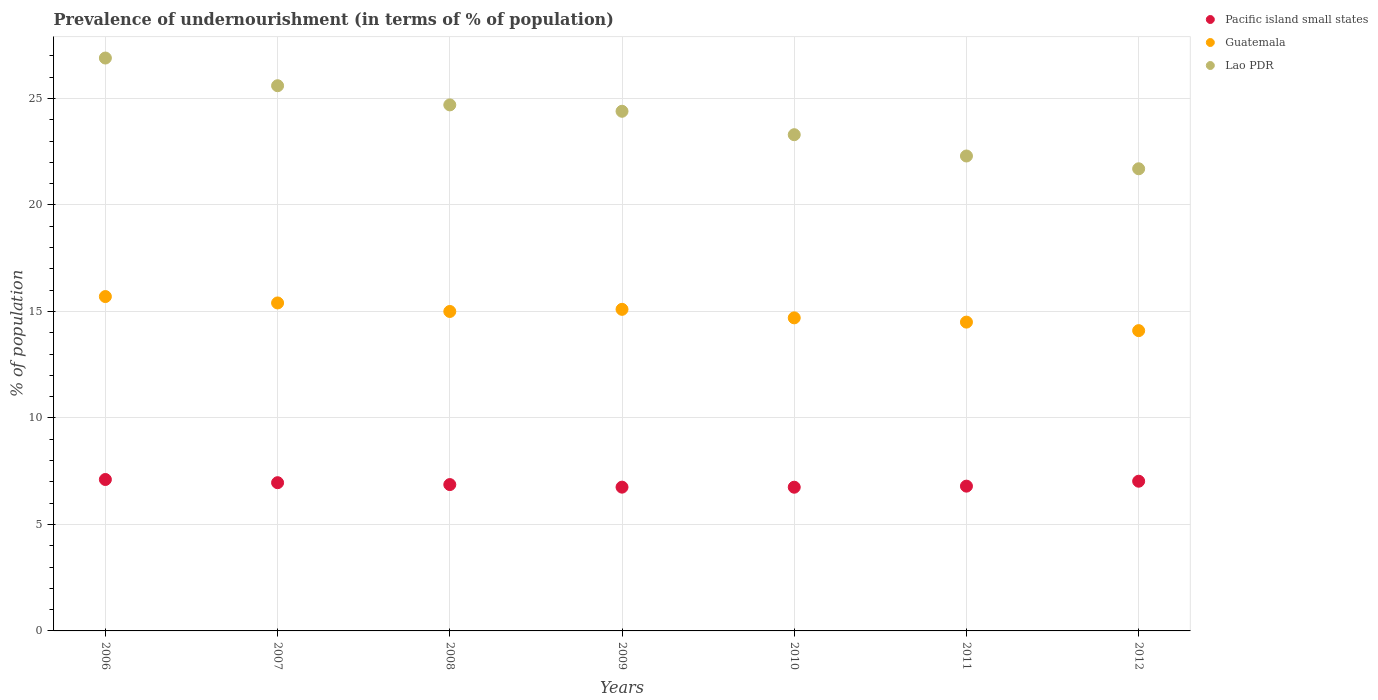Is the number of dotlines equal to the number of legend labels?
Make the answer very short. Yes. What is the percentage of undernourished population in Guatemala in 2009?
Offer a terse response. 15.1. Across all years, what is the minimum percentage of undernourished population in Lao PDR?
Make the answer very short. 21.7. In which year was the percentage of undernourished population in Guatemala maximum?
Your response must be concise. 2006. In which year was the percentage of undernourished population in Guatemala minimum?
Keep it short and to the point. 2012. What is the total percentage of undernourished population in Lao PDR in the graph?
Keep it short and to the point. 168.9. What is the difference between the percentage of undernourished population in Pacific island small states in 2010 and that in 2012?
Your answer should be compact. -0.28. What is the difference between the percentage of undernourished population in Lao PDR in 2011 and the percentage of undernourished population in Pacific island small states in 2010?
Provide a short and direct response. 15.55. What is the average percentage of undernourished population in Pacific island small states per year?
Provide a succinct answer. 6.9. In the year 2009, what is the difference between the percentage of undernourished population in Guatemala and percentage of undernourished population in Pacific island small states?
Provide a short and direct response. 8.35. What is the ratio of the percentage of undernourished population in Pacific island small states in 2009 to that in 2011?
Your answer should be compact. 0.99. Is the percentage of undernourished population in Lao PDR in 2008 less than that in 2009?
Give a very brief answer. No. What is the difference between the highest and the second highest percentage of undernourished population in Guatemala?
Offer a very short reply. 0.3. What is the difference between the highest and the lowest percentage of undernourished population in Pacific island small states?
Provide a short and direct response. 0.36. Is the percentage of undernourished population in Guatemala strictly greater than the percentage of undernourished population in Lao PDR over the years?
Give a very brief answer. No. Is the percentage of undernourished population in Guatemala strictly less than the percentage of undernourished population in Lao PDR over the years?
Your answer should be very brief. Yes. How many dotlines are there?
Your answer should be compact. 3. How many years are there in the graph?
Provide a succinct answer. 7. What is the difference between two consecutive major ticks on the Y-axis?
Offer a very short reply. 5. Are the values on the major ticks of Y-axis written in scientific E-notation?
Provide a succinct answer. No. Where does the legend appear in the graph?
Make the answer very short. Top right. How are the legend labels stacked?
Offer a very short reply. Vertical. What is the title of the graph?
Give a very brief answer. Prevalence of undernourishment (in terms of % of population). What is the label or title of the Y-axis?
Your answer should be compact. % of population. What is the % of population of Pacific island small states in 2006?
Provide a succinct answer. 7.11. What is the % of population of Lao PDR in 2006?
Your response must be concise. 26.9. What is the % of population in Pacific island small states in 2007?
Offer a very short reply. 6.96. What is the % of population in Lao PDR in 2007?
Provide a succinct answer. 25.6. What is the % of population in Pacific island small states in 2008?
Your answer should be compact. 6.87. What is the % of population of Guatemala in 2008?
Your answer should be very brief. 15. What is the % of population in Lao PDR in 2008?
Make the answer very short. 24.7. What is the % of population of Pacific island small states in 2009?
Your answer should be very brief. 6.75. What is the % of population of Lao PDR in 2009?
Offer a terse response. 24.4. What is the % of population of Pacific island small states in 2010?
Ensure brevity in your answer.  6.75. What is the % of population of Lao PDR in 2010?
Ensure brevity in your answer.  23.3. What is the % of population of Pacific island small states in 2011?
Your answer should be very brief. 6.8. What is the % of population in Lao PDR in 2011?
Your response must be concise. 22.3. What is the % of population of Pacific island small states in 2012?
Provide a short and direct response. 7.03. What is the % of population of Guatemala in 2012?
Provide a short and direct response. 14.1. What is the % of population of Lao PDR in 2012?
Give a very brief answer. 21.7. Across all years, what is the maximum % of population of Pacific island small states?
Your response must be concise. 7.11. Across all years, what is the maximum % of population in Lao PDR?
Give a very brief answer. 26.9. Across all years, what is the minimum % of population in Pacific island small states?
Ensure brevity in your answer.  6.75. Across all years, what is the minimum % of population of Guatemala?
Give a very brief answer. 14.1. Across all years, what is the minimum % of population of Lao PDR?
Give a very brief answer. 21.7. What is the total % of population in Pacific island small states in the graph?
Your answer should be very brief. 48.27. What is the total % of population in Guatemala in the graph?
Make the answer very short. 104.5. What is the total % of population of Lao PDR in the graph?
Ensure brevity in your answer.  168.9. What is the difference between the % of population of Pacific island small states in 2006 and that in 2007?
Provide a succinct answer. 0.15. What is the difference between the % of population of Guatemala in 2006 and that in 2007?
Your answer should be compact. 0.3. What is the difference between the % of population of Pacific island small states in 2006 and that in 2008?
Your answer should be compact. 0.24. What is the difference between the % of population of Guatemala in 2006 and that in 2008?
Give a very brief answer. 0.7. What is the difference between the % of population in Pacific island small states in 2006 and that in 2009?
Offer a terse response. 0.36. What is the difference between the % of population in Guatemala in 2006 and that in 2009?
Your answer should be very brief. 0.6. What is the difference between the % of population in Lao PDR in 2006 and that in 2009?
Ensure brevity in your answer.  2.5. What is the difference between the % of population of Pacific island small states in 2006 and that in 2010?
Keep it short and to the point. 0.36. What is the difference between the % of population in Guatemala in 2006 and that in 2010?
Offer a terse response. 1. What is the difference between the % of population in Lao PDR in 2006 and that in 2010?
Keep it short and to the point. 3.6. What is the difference between the % of population of Pacific island small states in 2006 and that in 2011?
Give a very brief answer. 0.31. What is the difference between the % of population in Lao PDR in 2006 and that in 2011?
Provide a short and direct response. 4.6. What is the difference between the % of population in Pacific island small states in 2006 and that in 2012?
Make the answer very short. 0.08. What is the difference between the % of population in Pacific island small states in 2007 and that in 2008?
Give a very brief answer. 0.09. What is the difference between the % of population of Guatemala in 2007 and that in 2008?
Provide a short and direct response. 0.4. What is the difference between the % of population of Lao PDR in 2007 and that in 2008?
Provide a succinct answer. 0.9. What is the difference between the % of population in Pacific island small states in 2007 and that in 2009?
Offer a terse response. 0.21. What is the difference between the % of population of Lao PDR in 2007 and that in 2009?
Offer a very short reply. 1.2. What is the difference between the % of population in Pacific island small states in 2007 and that in 2010?
Keep it short and to the point. 0.21. What is the difference between the % of population of Guatemala in 2007 and that in 2010?
Provide a succinct answer. 0.7. What is the difference between the % of population in Lao PDR in 2007 and that in 2010?
Give a very brief answer. 2.3. What is the difference between the % of population of Pacific island small states in 2007 and that in 2011?
Offer a very short reply. 0.16. What is the difference between the % of population of Lao PDR in 2007 and that in 2011?
Your answer should be compact. 3.3. What is the difference between the % of population in Pacific island small states in 2007 and that in 2012?
Ensure brevity in your answer.  -0.07. What is the difference between the % of population of Lao PDR in 2007 and that in 2012?
Your answer should be compact. 3.9. What is the difference between the % of population in Pacific island small states in 2008 and that in 2009?
Make the answer very short. 0.12. What is the difference between the % of population of Guatemala in 2008 and that in 2009?
Offer a very short reply. -0.1. What is the difference between the % of population in Lao PDR in 2008 and that in 2009?
Your answer should be compact. 0.3. What is the difference between the % of population of Pacific island small states in 2008 and that in 2010?
Make the answer very short. 0.12. What is the difference between the % of population in Pacific island small states in 2008 and that in 2011?
Make the answer very short. 0.07. What is the difference between the % of population of Lao PDR in 2008 and that in 2011?
Provide a succinct answer. 2.4. What is the difference between the % of population in Pacific island small states in 2008 and that in 2012?
Provide a succinct answer. -0.16. What is the difference between the % of population in Lao PDR in 2008 and that in 2012?
Offer a very short reply. 3. What is the difference between the % of population in Pacific island small states in 2009 and that in 2010?
Provide a short and direct response. 0. What is the difference between the % of population in Guatemala in 2009 and that in 2010?
Offer a terse response. 0.4. What is the difference between the % of population of Lao PDR in 2009 and that in 2010?
Offer a very short reply. 1.1. What is the difference between the % of population in Pacific island small states in 2009 and that in 2011?
Provide a short and direct response. -0.05. What is the difference between the % of population of Guatemala in 2009 and that in 2011?
Give a very brief answer. 0.6. What is the difference between the % of population in Lao PDR in 2009 and that in 2011?
Your answer should be very brief. 2.1. What is the difference between the % of population in Pacific island small states in 2009 and that in 2012?
Ensure brevity in your answer.  -0.28. What is the difference between the % of population of Guatemala in 2009 and that in 2012?
Provide a succinct answer. 1. What is the difference between the % of population in Lao PDR in 2009 and that in 2012?
Keep it short and to the point. 2.7. What is the difference between the % of population of Pacific island small states in 2010 and that in 2011?
Provide a succinct answer. -0.05. What is the difference between the % of population in Lao PDR in 2010 and that in 2011?
Your answer should be compact. 1. What is the difference between the % of population in Pacific island small states in 2010 and that in 2012?
Your answer should be very brief. -0.28. What is the difference between the % of population of Pacific island small states in 2011 and that in 2012?
Make the answer very short. -0.23. What is the difference between the % of population of Lao PDR in 2011 and that in 2012?
Offer a terse response. 0.6. What is the difference between the % of population in Pacific island small states in 2006 and the % of population in Guatemala in 2007?
Ensure brevity in your answer.  -8.29. What is the difference between the % of population in Pacific island small states in 2006 and the % of population in Lao PDR in 2007?
Make the answer very short. -18.49. What is the difference between the % of population in Guatemala in 2006 and the % of population in Lao PDR in 2007?
Offer a very short reply. -9.9. What is the difference between the % of population of Pacific island small states in 2006 and the % of population of Guatemala in 2008?
Offer a terse response. -7.89. What is the difference between the % of population in Pacific island small states in 2006 and the % of population in Lao PDR in 2008?
Keep it short and to the point. -17.59. What is the difference between the % of population in Guatemala in 2006 and the % of population in Lao PDR in 2008?
Keep it short and to the point. -9. What is the difference between the % of population of Pacific island small states in 2006 and the % of population of Guatemala in 2009?
Your answer should be very brief. -7.99. What is the difference between the % of population of Pacific island small states in 2006 and the % of population of Lao PDR in 2009?
Your answer should be very brief. -17.29. What is the difference between the % of population in Guatemala in 2006 and the % of population in Lao PDR in 2009?
Make the answer very short. -8.7. What is the difference between the % of population of Pacific island small states in 2006 and the % of population of Guatemala in 2010?
Provide a short and direct response. -7.59. What is the difference between the % of population in Pacific island small states in 2006 and the % of population in Lao PDR in 2010?
Make the answer very short. -16.19. What is the difference between the % of population in Pacific island small states in 2006 and the % of population in Guatemala in 2011?
Offer a very short reply. -7.39. What is the difference between the % of population in Pacific island small states in 2006 and the % of population in Lao PDR in 2011?
Ensure brevity in your answer.  -15.19. What is the difference between the % of population in Guatemala in 2006 and the % of population in Lao PDR in 2011?
Offer a terse response. -6.6. What is the difference between the % of population of Pacific island small states in 2006 and the % of population of Guatemala in 2012?
Provide a short and direct response. -6.99. What is the difference between the % of population of Pacific island small states in 2006 and the % of population of Lao PDR in 2012?
Provide a succinct answer. -14.59. What is the difference between the % of population in Pacific island small states in 2007 and the % of population in Guatemala in 2008?
Provide a succinct answer. -8.04. What is the difference between the % of population in Pacific island small states in 2007 and the % of population in Lao PDR in 2008?
Offer a very short reply. -17.74. What is the difference between the % of population in Guatemala in 2007 and the % of population in Lao PDR in 2008?
Ensure brevity in your answer.  -9.3. What is the difference between the % of population in Pacific island small states in 2007 and the % of population in Guatemala in 2009?
Give a very brief answer. -8.14. What is the difference between the % of population of Pacific island small states in 2007 and the % of population of Lao PDR in 2009?
Keep it short and to the point. -17.44. What is the difference between the % of population in Pacific island small states in 2007 and the % of population in Guatemala in 2010?
Provide a short and direct response. -7.74. What is the difference between the % of population in Pacific island small states in 2007 and the % of population in Lao PDR in 2010?
Ensure brevity in your answer.  -16.34. What is the difference between the % of population of Guatemala in 2007 and the % of population of Lao PDR in 2010?
Offer a terse response. -7.9. What is the difference between the % of population of Pacific island small states in 2007 and the % of population of Guatemala in 2011?
Offer a terse response. -7.54. What is the difference between the % of population in Pacific island small states in 2007 and the % of population in Lao PDR in 2011?
Your answer should be very brief. -15.34. What is the difference between the % of population in Pacific island small states in 2007 and the % of population in Guatemala in 2012?
Ensure brevity in your answer.  -7.14. What is the difference between the % of population of Pacific island small states in 2007 and the % of population of Lao PDR in 2012?
Your answer should be very brief. -14.74. What is the difference between the % of population of Pacific island small states in 2008 and the % of population of Guatemala in 2009?
Your answer should be very brief. -8.23. What is the difference between the % of population of Pacific island small states in 2008 and the % of population of Lao PDR in 2009?
Your answer should be compact. -17.53. What is the difference between the % of population of Pacific island small states in 2008 and the % of population of Guatemala in 2010?
Keep it short and to the point. -7.83. What is the difference between the % of population in Pacific island small states in 2008 and the % of population in Lao PDR in 2010?
Provide a short and direct response. -16.43. What is the difference between the % of population of Guatemala in 2008 and the % of population of Lao PDR in 2010?
Your answer should be compact. -8.3. What is the difference between the % of population of Pacific island small states in 2008 and the % of population of Guatemala in 2011?
Your answer should be compact. -7.63. What is the difference between the % of population of Pacific island small states in 2008 and the % of population of Lao PDR in 2011?
Ensure brevity in your answer.  -15.43. What is the difference between the % of population in Guatemala in 2008 and the % of population in Lao PDR in 2011?
Your response must be concise. -7.3. What is the difference between the % of population in Pacific island small states in 2008 and the % of population in Guatemala in 2012?
Make the answer very short. -7.23. What is the difference between the % of population of Pacific island small states in 2008 and the % of population of Lao PDR in 2012?
Give a very brief answer. -14.83. What is the difference between the % of population in Guatemala in 2008 and the % of population in Lao PDR in 2012?
Provide a succinct answer. -6.7. What is the difference between the % of population in Pacific island small states in 2009 and the % of population in Guatemala in 2010?
Your response must be concise. -7.95. What is the difference between the % of population in Pacific island small states in 2009 and the % of population in Lao PDR in 2010?
Provide a succinct answer. -16.55. What is the difference between the % of population of Pacific island small states in 2009 and the % of population of Guatemala in 2011?
Offer a terse response. -7.75. What is the difference between the % of population of Pacific island small states in 2009 and the % of population of Lao PDR in 2011?
Keep it short and to the point. -15.55. What is the difference between the % of population in Pacific island small states in 2009 and the % of population in Guatemala in 2012?
Ensure brevity in your answer.  -7.35. What is the difference between the % of population in Pacific island small states in 2009 and the % of population in Lao PDR in 2012?
Offer a very short reply. -14.95. What is the difference between the % of population in Guatemala in 2009 and the % of population in Lao PDR in 2012?
Keep it short and to the point. -6.6. What is the difference between the % of population of Pacific island small states in 2010 and the % of population of Guatemala in 2011?
Offer a terse response. -7.75. What is the difference between the % of population in Pacific island small states in 2010 and the % of population in Lao PDR in 2011?
Provide a short and direct response. -15.55. What is the difference between the % of population of Guatemala in 2010 and the % of population of Lao PDR in 2011?
Give a very brief answer. -7.6. What is the difference between the % of population of Pacific island small states in 2010 and the % of population of Guatemala in 2012?
Give a very brief answer. -7.35. What is the difference between the % of population of Pacific island small states in 2010 and the % of population of Lao PDR in 2012?
Provide a succinct answer. -14.95. What is the difference between the % of population of Guatemala in 2010 and the % of population of Lao PDR in 2012?
Your answer should be very brief. -7. What is the difference between the % of population in Pacific island small states in 2011 and the % of population in Guatemala in 2012?
Offer a very short reply. -7.3. What is the difference between the % of population in Pacific island small states in 2011 and the % of population in Lao PDR in 2012?
Your answer should be compact. -14.9. What is the average % of population of Pacific island small states per year?
Your response must be concise. 6.9. What is the average % of population in Guatemala per year?
Provide a short and direct response. 14.93. What is the average % of population in Lao PDR per year?
Make the answer very short. 24.13. In the year 2006, what is the difference between the % of population in Pacific island small states and % of population in Guatemala?
Offer a very short reply. -8.59. In the year 2006, what is the difference between the % of population in Pacific island small states and % of population in Lao PDR?
Make the answer very short. -19.79. In the year 2006, what is the difference between the % of population in Guatemala and % of population in Lao PDR?
Offer a terse response. -11.2. In the year 2007, what is the difference between the % of population of Pacific island small states and % of population of Guatemala?
Provide a succinct answer. -8.44. In the year 2007, what is the difference between the % of population of Pacific island small states and % of population of Lao PDR?
Make the answer very short. -18.64. In the year 2007, what is the difference between the % of population in Guatemala and % of population in Lao PDR?
Make the answer very short. -10.2. In the year 2008, what is the difference between the % of population of Pacific island small states and % of population of Guatemala?
Give a very brief answer. -8.13. In the year 2008, what is the difference between the % of population of Pacific island small states and % of population of Lao PDR?
Offer a very short reply. -17.83. In the year 2009, what is the difference between the % of population in Pacific island small states and % of population in Guatemala?
Provide a succinct answer. -8.35. In the year 2009, what is the difference between the % of population in Pacific island small states and % of population in Lao PDR?
Give a very brief answer. -17.65. In the year 2010, what is the difference between the % of population in Pacific island small states and % of population in Guatemala?
Your answer should be compact. -7.95. In the year 2010, what is the difference between the % of population of Pacific island small states and % of population of Lao PDR?
Provide a short and direct response. -16.55. In the year 2010, what is the difference between the % of population of Guatemala and % of population of Lao PDR?
Offer a very short reply. -8.6. In the year 2011, what is the difference between the % of population in Pacific island small states and % of population in Guatemala?
Ensure brevity in your answer.  -7.7. In the year 2011, what is the difference between the % of population of Pacific island small states and % of population of Lao PDR?
Make the answer very short. -15.5. In the year 2012, what is the difference between the % of population of Pacific island small states and % of population of Guatemala?
Your response must be concise. -7.07. In the year 2012, what is the difference between the % of population in Pacific island small states and % of population in Lao PDR?
Your response must be concise. -14.67. What is the ratio of the % of population in Pacific island small states in 2006 to that in 2007?
Provide a short and direct response. 1.02. What is the ratio of the % of population in Guatemala in 2006 to that in 2007?
Your answer should be very brief. 1.02. What is the ratio of the % of population of Lao PDR in 2006 to that in 2007?
Your response must be concise. 1.05. What is the ratio of the % of population in Pacific island small states in 2006 to that in 2008?
Provide a short and direct response. 1.03. What is the ratio of the % of population of Guatemala in 2006 to that in 2008?
Provide a short and direct response. 1.05. What is the ratio of the % of population in Lao PDR in 2006 to that in 2008?
Offer a terse response. 1.09. What is the ratio of the % of population in Pacific island small states in 2006 to that in 2009?
Ensure brevity in your answer.  1.05. What is the ratio of the % of population of Guatemala in 2006 to that in 2009?
Give a very brief answer. 1.04. What is the ratio of the % of population in Lao PDR in 2006 to that in 2009?
Offer a terse response. 1.1. What is the ratio of the % of population of Pacific island small states in 2006 to that in 2010?
Ensure brevity in your answer.  1.05. What is the ratio of the % of population in Guatemala in 2006 to that in 2010?
Ensure brevity in your answer.  1.07. What is the ratio of the % of population of Lao PDR in 2006 to that in 2010?
Provide a succinct answer. 1.15. What is the ratio of the % of population of Pacific island small states in 2006 to that in 2011?
Provide a short and direct response. 1.05. What is the ratio of the % of population in Guatemala in 2006 to that in 2011?
Your answer should be compact. 1.08. What is the ratio of the % of population in Lao PDR in 2006 to that in 2011?
Offer a terse response. 1.21. What is the ratio of the % of population in Pacific island small states in 2006 to that in 2012?
Your response must be concise. 1.01. What is the ratio of the % of population of Guatemala in 2006 to that in 2012?
Offer a very short reply. 1.11. What is the ratio of the % of population of Lao PDR in 2006 to that in 2012?
Offer a very short reply. 1.24. What is the ratio of the % of population in Pacific island small states in 2007 to that in 2008?
Provide a short and direct response. 1.01. What is the ratio of the % of population of Guatemala in 2007 to that in 2008?
Give a very brief answer. 1.03. What is the ratio of the % of population in Lao PDR in 2007 to that in 2008?
Provide a succinct answer. 1.04. What is the ratio of the % of population in Pacific island small states in 2007 to that in 2009?
Offer a terse response. 1.03. What is the ratio of the % of population in Guatemala in 2007 to that in 2009?
Ensure brevity in your answer.  1.02. What is the ratio of the % of population of Lao PDR in 2007 to that in 2009?
Ensure brevity in your answer.  1.05. What is the ratio of the % of population of Pacific island small states in 2007 to that in 2010?
Your answer should be very brief. 1.03. What is the ratio of the % of population in Guatemala in 2007 to that in 2010?
Give a very brief answer. 1.05. What is the ratio of the % of population in Lao PDR in 2007 to that in 2010?
Ensure brevity in your answer.  1.1. What is the ratio of the % of population of Pacific island small states in 2007 to that in 2011?
Keep it short and to the point. 1.02. What is the ratio of the % of population in Guatemala in 2007 to that in 2011?
Make the answer very short. 1.06. What is the ratio of the % of population in Lao PDR in 2007 to that in 2011?
Provide a succinct answer. 1.15. What is the ratio of the % of population in Guatemala in 2007 to that in 2012?
Make the answer very short. 1.09. What is the ratio of the % of population in Lao PDR in 2007 to that in 2012?
Your answer should be compact. 1.18. What is the ratio of the % of population in Pacific island small states in 2008 to that in 2009?
Your answer should be very brief. 1.02. What is the ratio of the % of population of Lao PDR in 2008 to that in 2009?
Your response must be concise. 1.01. What is the ratio of the % of population of Pacific island small states in 2008 to that in 2010?
Ensure brevity in your answer.  1.02. What is the ratio of the % of population of Guatemala in 2008 to that in 2010?
Provide a short and direct response. 1.02. What is the ratio of the % of population of Lao PDR in 2008 to that in 2010?
Provide a succinct answer. 1.06. What is the ratio of the % of population of Pacific island small states in 2008 to that in 2011?
Your response must be concise. 1.01. What is the ratio of the % of population in Guatemala in 2008 to that in 2011?
Keep it short and to the point. 1.03. What is the ratio of the % of population in Lao PDR in 2008 to that in 2011?
Keep it short and to the point. 1.11. What is the ratio of the % of population of Pacific island small states in 2008 to that in 2012?
Ensure brevity in your answer.  0.98. What is the ratio of the % of population of Guatemala in 2008 to that in 2012?
Provide a short and direct response. 1.06. What is the ratio of the % of population of Lao PDR in 2008 to that in 2012?
Your answer should be compact. 1.14. What is the ratio of the % of population of Pacific island small states in 2009 to that in 2010?
Offer a very short reply. 1. What is the ratio of the % of population in Guatemala in 2009 to that in 2010?
Your answer should be very brief. 1.03. What is the ratio of the % of population of Lao PDR in 2009 to that in 2010?
Your answer should be compact. 1.05. What is the ratio of the % of population of Guatemala in 2009 to that in 2011?
Offer a very short reply. 1.04. What is the ratio of the % of population of Lao PDR in 2009 to that in 2011?
Your answer should be very brief. 1.09. What is the ratio of the % of population of Pacific island small states in 2009 to that in 2012?
Provide a short and direct response. 0.96. What is the ratio of the % of population of Guatemala in 2009 to that in 2012?
Your response must be concise. 1.07. What is the ratio of the % of population in Lao PDR in 2009 to that in 2012?
Ensure brevity in your answer.  1.12. What is the ratio of the % of population of Pacific island small states in 2010 to that in 2011?
Keep it short and to the point. 0.99. What is the ratio of the % of population of Guatemala in 2010 to that in 2011?
Provide a short and direct response. 1.01. What is the ratio of the % of population of Lao PDR in 2010 to that in 2011?
Your answer should be very brief. 1.04. What is the ratio of the % of population in Guatemala in 2010 to that in 2012?
Your answer should be very brief. 1.04. What is the ratio of the % of population in Lao PDR in 2010 to that in 2012?
Ensure brevity in your answer.  1.07. What is the ratio of the % of population in Pacific island small states in 2011 to that in 2012?
Make the answer very short. 0.97. What is the ratio of the % of population in Guatemala in 2011 to that in 2012?
Make the answer very short. 1.03. What is the ratio of the % of population of Lao PDR in 2011 to that in 2012?
Provide a succinct answer. 1.03. What is the difference between the highest and the second highest % of population of Pacific island small states?
Provide a succinct answer. 0.08. What is the difference between the highest and the second highest % of population in Lao PDR?
Give a very brief answer. 1.3. What is the difference between the highest and the lowest % of population of Pacific island small states?
Provide a succinct answer. 0.36. What is the difference between the highest and the lowest % of population in Lao PDR?
Make the answer very short. 5.2. 